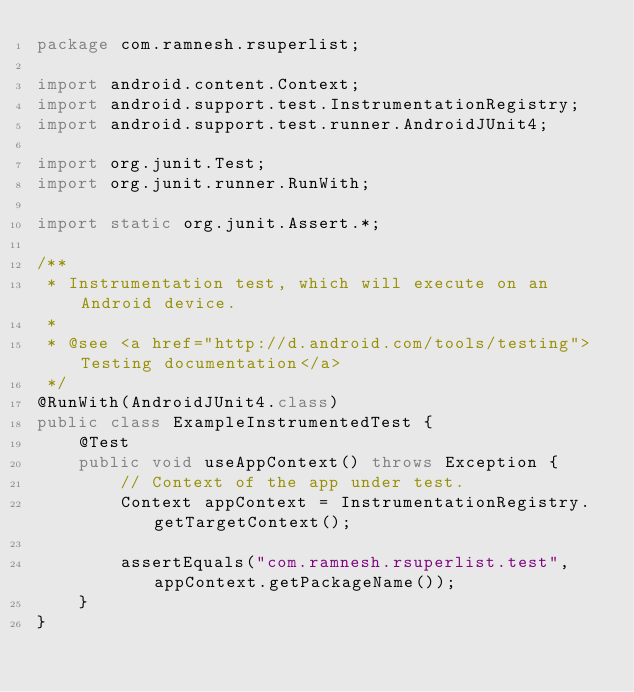Convert code to text. <code><loc_0><loc_0><loc_500><loc_500><_Java_>package com.ramnesh.rsuperlist;

import android.content.Context;
import android.support.test.InstrumentationRegistry;
import android.support.test.runner.AndroidJUnit4;

import org.junit.Test;
import org.junit.runner.RunWith;

import static org.junit.Assert.*;

/**
 * Instrumentation test, which will execute on an Android device.
 *
 * @see <a href="http://d.android.com/tools/testing">Testing documentation</a>
 */
@RunWith(AndroidJUnit4.class)
public class ExampleInstrumentedTest {
    @Test
    public void useAppContext() throws Exception {
        // Context of the app under test.
        Context appContext = InstrumentationRegistry.getTargetContext();

        assertEquals("com.ramnesh.rsuperlist.test", appContext.getPackageName());
    }
}
</code> 